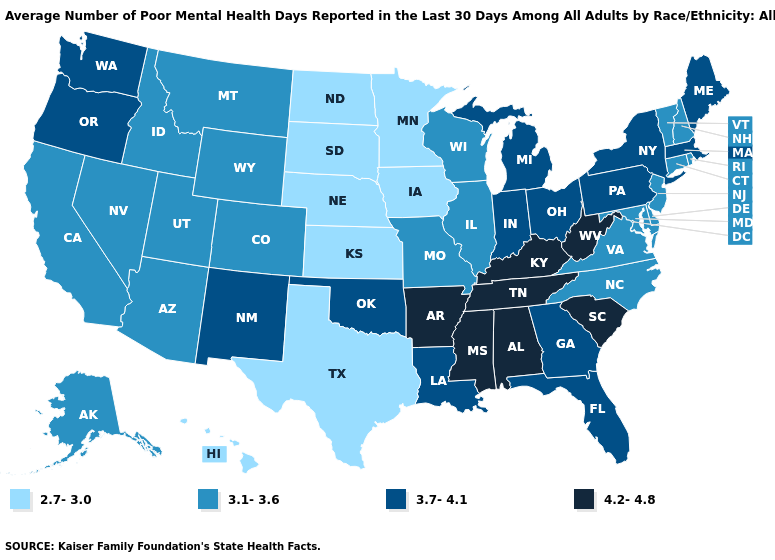Which states have the highest value in the USA?
Keep it brief. Alabama, Arkansas, Kentucky, Mississippi, South Carolina, Tennessee, West Virginia. Name the states that have a value in the range 3.7-4.1?
Quick response, please. Florida, Georgia, Indiana, Louisiana, Maine, Massachusetts, Michigan, New Mexico, New York, Ohio, Oklahoma, Oregon, Pennsylvania, Washington. Which states have the highest value in the USA?
Short answer required. Alabama, Arkansas, Kentucky, Mississippi, South Carolina, Tennessee, West Virginia. What is the value of Missouri?
Answer briefly. 3.1-3.6. Which states hav the highest value in the Northeast?
Concise answer only. Maine, Massachusetts, New York, Pennsylvania. Name the states that have a value in the range 3.7-4.1?
Keep it brief. Florida, Georgia, Indiana, Louisiana, Maine, Massachusetts, Michigan, New Mexico, New York, Ohio, Oklahoma, Oregon, Pennsylvania, Washington. Is the legend a continuous bar?
Concise answer only. No. What is the value of Wisconsin?
Quick response, please. 3.1-3.6. Does the first symbol in the legend represent the smallest category?
Write a very short answer. Yes. Does Wisconsin have the lowest value in the MidWest?
Concise answer only. No. Among the states that border Arizona , does New Mexico have the lowest value?
Keep it brief. No. Is the legend a continuous bar?
Short answer required. No. Which states have the lowest value in the USA?
Quick response, please. Hawaii, Iowa, Kansas, Minnesota, Nebraska, North Dakota, South Dakota, Texas. Name the states that have a value in the range 3.7-4.1?
Give a very brief answer. Florida, Georgia, Indiana, Louisiana, Maine, Massachusetts, Michigan, New Mexico, New York, Ohio, Oklahoma, Oregon, Pennsylvania, Washington. What is the value of New Hampshire?
Write a very short answer. 3.1-3.6. 